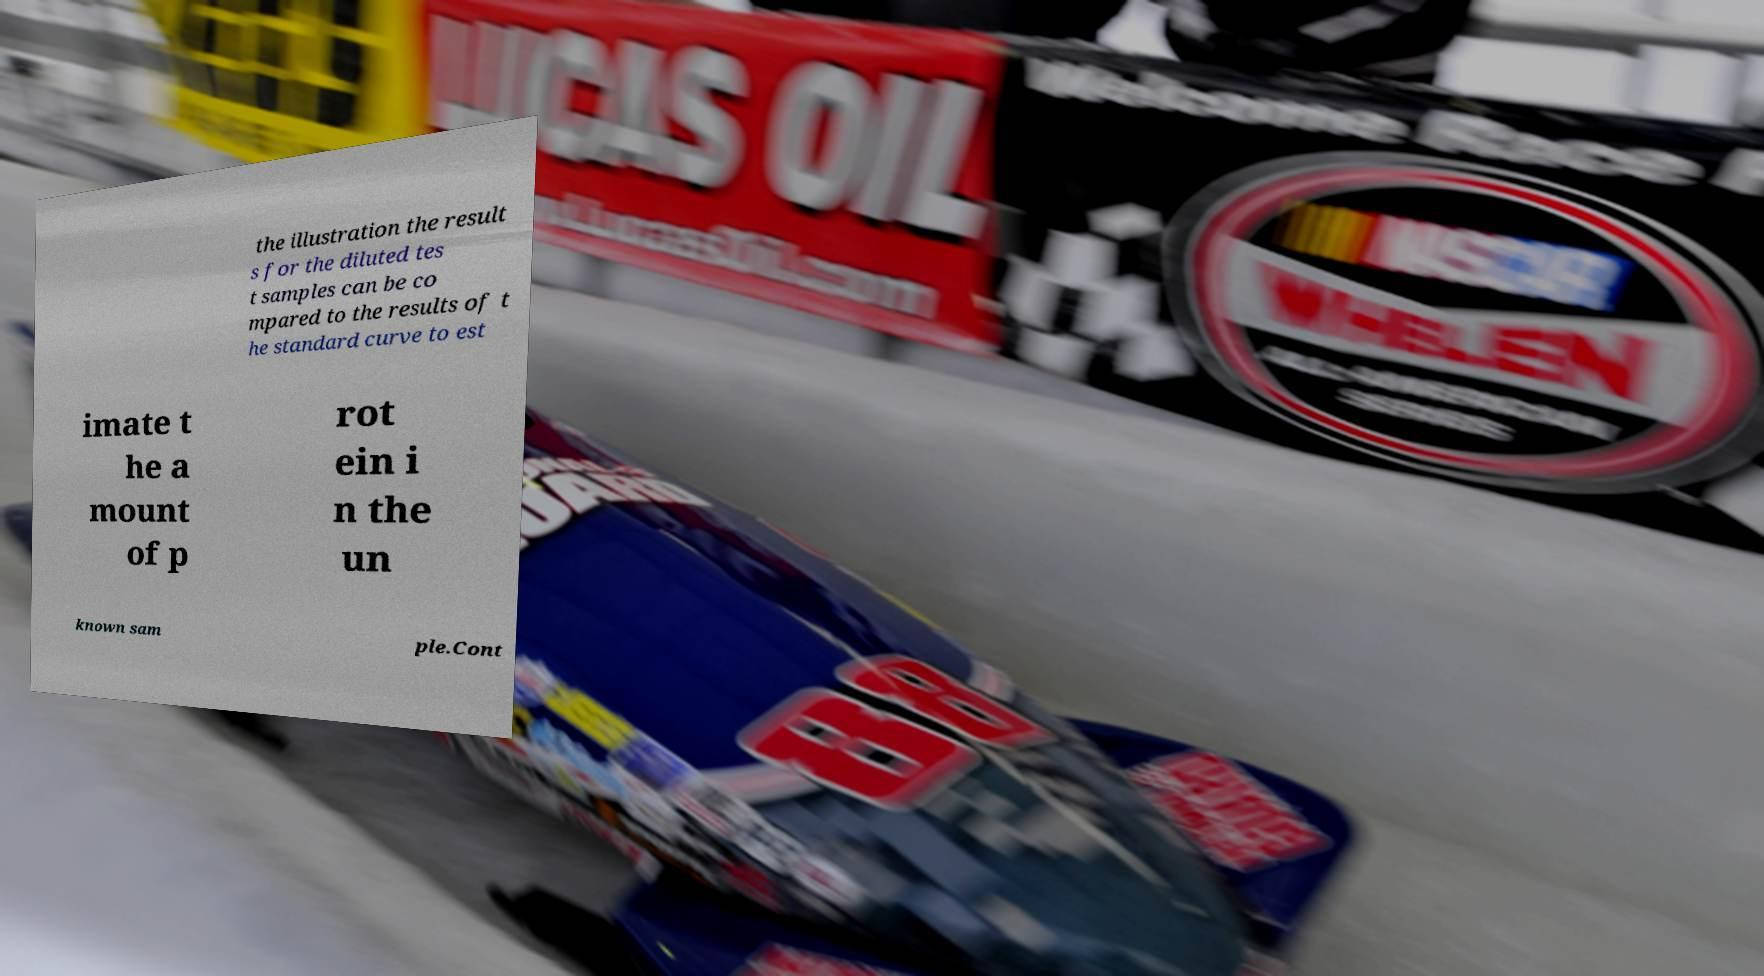What messages or text are displayed in this image? I need them in a readable, typed format. the illustration the result s for the diluted tes t samples can be co mpared to the results of t he standard curve to est imate t he a mount of p rot ein i n the un known sam ple.Cont 